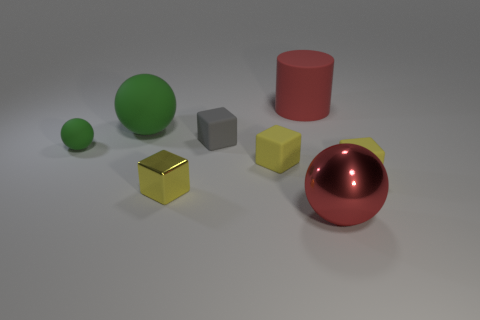There is a matte thing that is on the right side of the large thing on the right side of the big rubber cylinder; what color is it?
Make the answer very short. Yellow. The big cylinder is what color?
Provide a short and direct response. Red. Are there any large spheres of the same color as the cylinder?
Make the answer very short. Yes. Do the big sphere that is behind the big metallic thing and the small ball have the same color?
Keep it short and to the point. Yes. What number of things are things that are behind the metallic block or tiny matte things?
Provide a succinct answer. 6. Are there any big matte things on the right side of the gray rubber cube?
Make the answer very short. Yes. There is a large sphere that is the same color as the big cylinder; what is it made of?
Your answer should be very brief. Metal. Does the ball right of the metal block have the same material as the big cylinder?
Your answer should be very brief. No. There is a small yellow cube behind the matte block on the right side of the large metal sphere; are there any big spheres behind it?
Offer a terse response. Yes. How many cubes are either red matte things or tiny gray rubber objects?
Provide a short and direct response. 1. 